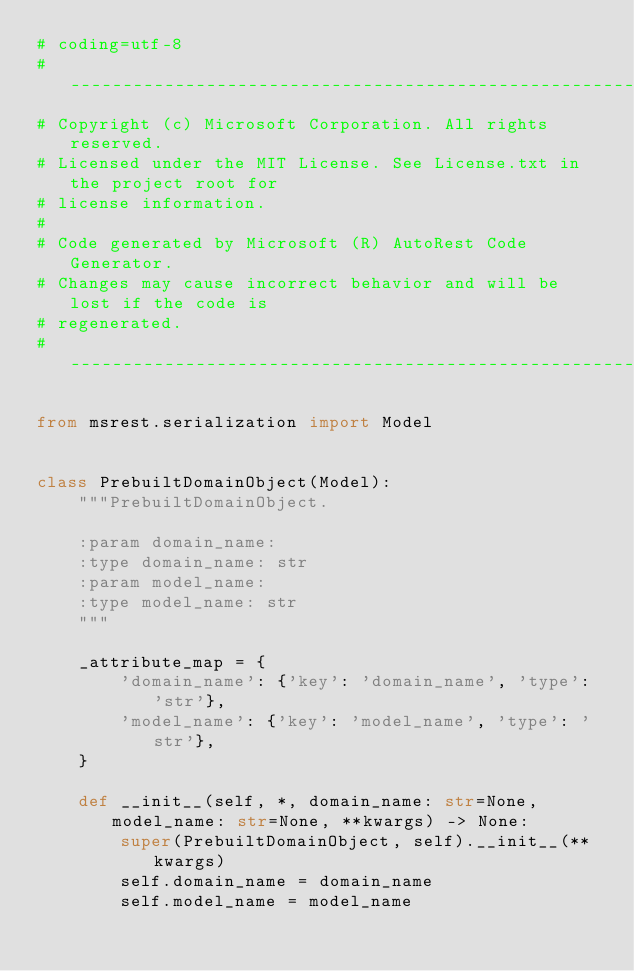Convert code to text. <code><loc_0><loc_0><loc_500><loc_500><_Python_># coding=utf-8
# --------------------------------------------------------------------------
# Copyright (c) Microsoft Corporation. All rights reserved.
# Licensed under the MIT License. See License.txt in the project root for
# license information.
#
# Code generated by Microsoft (R) AutoRest Code Generator.
# Changes may cause incorrect behavior and will be lost if the code is
# regenerated.
# --------------------------------------------------------------------------

from msrest.serialization import Model


class PrebuiltDomainObject(Model):
    """PrebuiltDomainObject.

    :param domain_name:
    :type domain_name: str
    :param model_name:
    :type model_name: str
    """

    _attribute_map = {
        'domain_name': {'key': 'domain_name', 'type': 'str'},
        'model_name': {'key': 'model_name', 'type': 'str'},
    }

    def __init__(self, *, domain_name: str=None, model_name: str=None, **kwargs) -> None:
        super(PrebuiltDomainObject, self).__init__(**kwargs)
        self.domain_name = domain_name
        self.model_name = model_name
</code> 